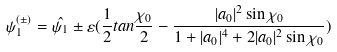Convert formula to latex. <formula><loc_0><loc_0><loc_500><loc_500>\psi _ { 1 } ^ { ( \pm ) } = \hat { \psi _ { 1 } } \pm \varepsilon ( \frac { 1 } { 2 } t a n \frac { \chi _ { 0 } } { 2 } - \frac { | a _ { 0 } | ^ { 2 } \sin \chi _ { 0 } } { 1 + | a _ { 0 } | ^ { 4 } + 2 | a _ { 0 } | ^ { 2 } \sin \chi _ { 0 } } )</formula> 